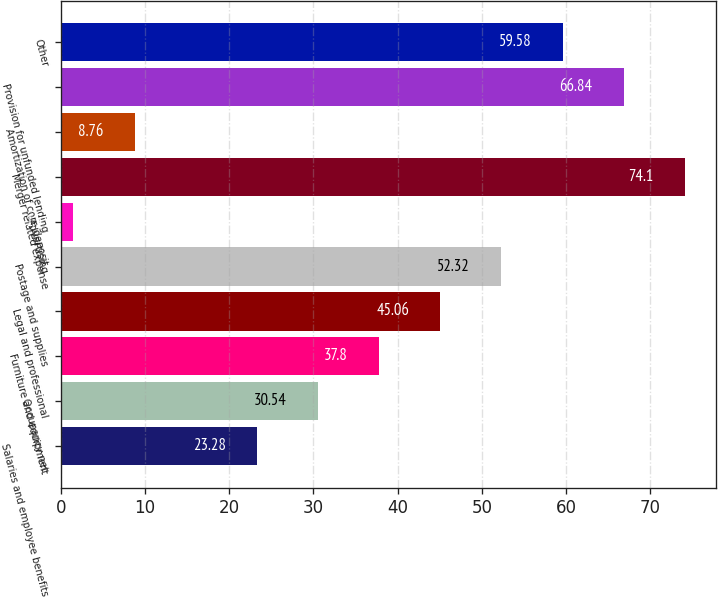<chart> <loc_0><loc_0><loc_500><loc_500><bar_chart><fcel>Salaries and employee benefits<fcel>Occupancy net<fcel>Furniture and equipment<fcel>Legal and professional<fcel>Postage and supplies<fcel>Advertising<fcel>Merger related expense<fcel>Amortization of core deposit<fcel>Provision for unfunded lending<fcel>Other<nl><fcel>23.28<fcel>30.54<fcel>37.8<fcel>45.06<fcel>52.32<fcel>1.5<fcel>74.1<fcel>8.76<fcel>66.84<fcel>59.58<nl></chart> 